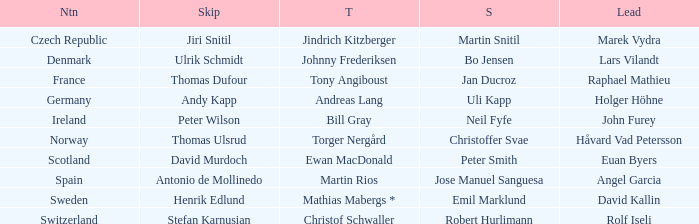Which leading figure manages a nation akin to switzerland? Rolf Iseli. 